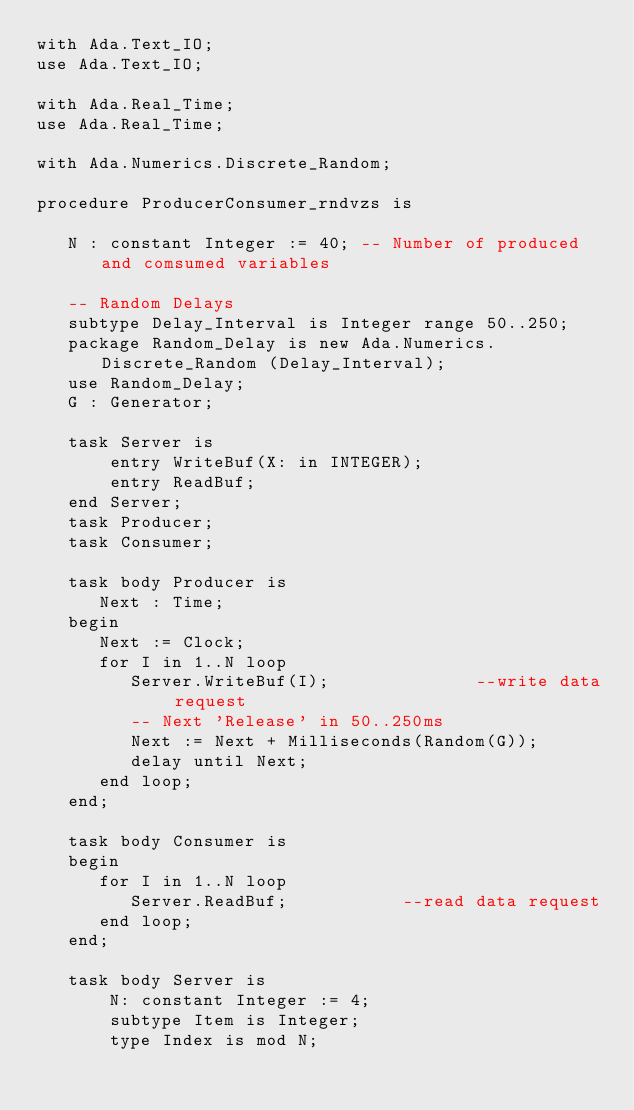<code> <loc_0><loc_0><loc_500><loc_500><_Ada_>with Ada.Text_IO;
use Ada.Text_IO;

with Ada.Real_Time;
use Ada.Real_Time;

with Ada.Numerics.Discrete_Random;

procedure ProducerConsumer_rndvzs is

   N : constant Integer := 40; -- Number of produced and comsumed variables

   -- Random Delays
   subtype Delay_Interval is Integer range 50..250;
   package Random_Delay is new Ada.Numerics.Discrete_Random (Delay_Interval);
   use Random_Delay;
   G : Generator;

   task Server is
       entry WriteBuf(X: in INTEGER);
       entry ReadBuf;
   end Server;
   task Producer;
   task Consumer;

   task body Producer is
      Next : Time;
   begin
      Next := Clock;
      for I in 1..N loop
         Server.WriteBuf(I);              --write data request
         -- Next 'Release' in 50..250ms
         Next := Next + Milliseconds(Random(G));
         delay until Next;
      end loop;
   end;

   task body Consumer is
   begin
      for I in 1..N loop
         Server.ReadBuf;           --read data request
      end loop;
   end;
   
   task body Server is
       N: constant Integer := 4;
       subtype Item is Integer;
       type Index is mod N;</code> 